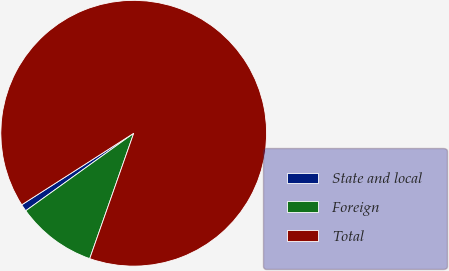Convert chart to OTSL. <chart><loc_0><loc_0><loc_500><loc_500><pie_chart><fcel>State and local<fcel>Foreign<fcel>Total<nl><fcel>0.86%<fcel>9.72%<fcel>89.42%<nl></chart> 